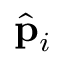Convert formula to latex. <formula><loc_0><loc_0><loc_500><loc_500>\hat { p } _ { i }</formula> 